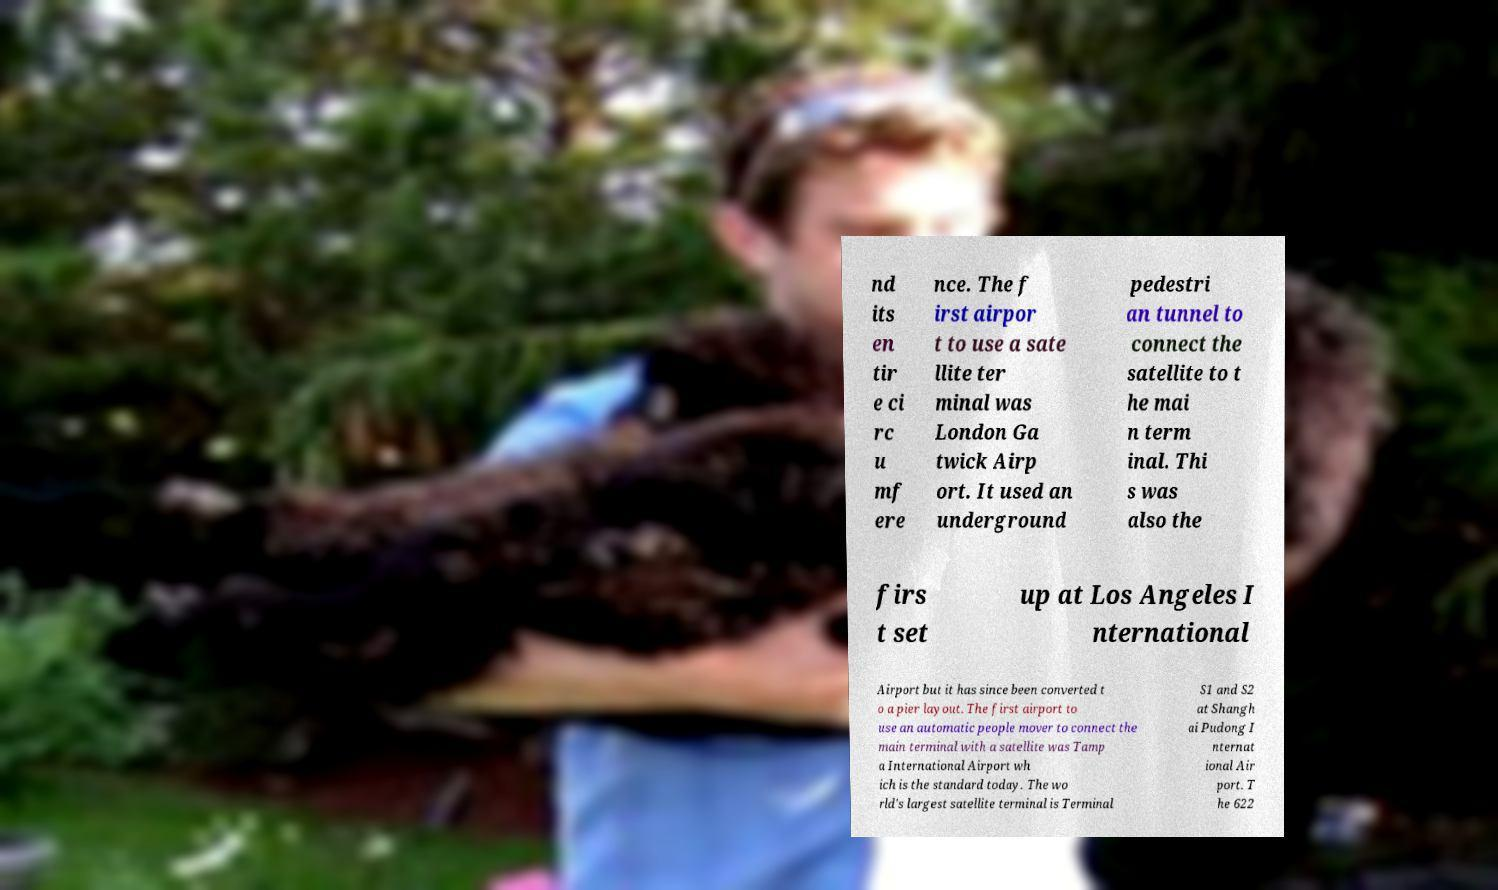Could you extract and type out the text from this image? nd its en tir e ci rc u mf ere nce. The f irst airpor t to use a sate llite ter minal was London Ga twick Airp ort. It used an underground pedestri an tunnel to connect the satellite to t he mai n term inal. Thi s was also the firs t set up at Los Angeles I nternational Airport but it has since been converted t o a pier layout. The first airport to use an automatic people mover to connect the main terminal with a satellite was Tamp a International Airport wh ich is the standard today. The wo rld's largest satellite terminal is Terminal S1 and S2 at Shangh ai Pudong I nternat ional Air port. T he 622 